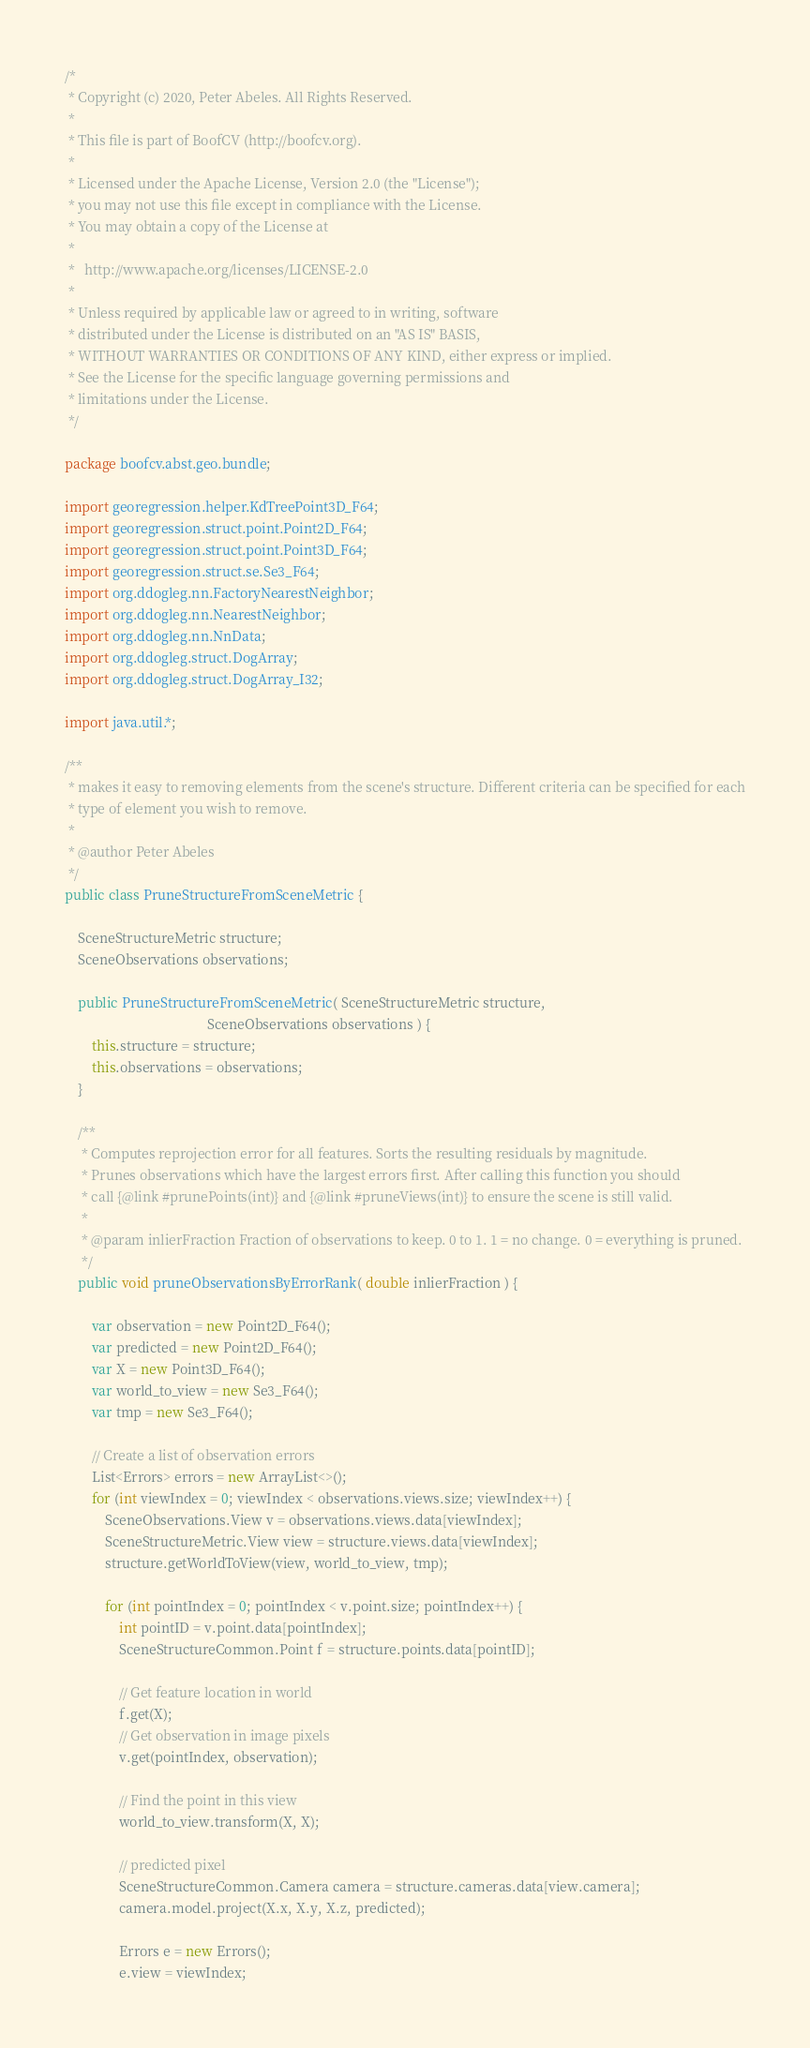Convert code to text. <code><loc_0><loc_0><loc_500><loc_500><_Java_>/*
 * Copyright (c) 2020, Peter Abeles. All Rights Reserved.
 *
 * This file is part of BoofCV (http://boofcv.org).
 *
 * Licensed under the Apache License, Version 2.0 (the "License");
 * you may not use this file except in compliance with the License.
 * You may obtain a copy of the License at
 *
 *   http://www.apache.org/licenses/LICENSE-2.0
 *
 * Unless required by applicable law or agreed to in writing, software
 * distributed under the License is distributed on an "AS IS" BASIS,
 * WITHOUT WARRANTIES OR CONDITIONS OF ANY KIND, either express or implied.
 * See the License for the specific language governing permissions and
 * limitations under the License.
 */

package boofcv.abst.geo.bundle;

import georegression.helper.KdTreePoint3D_F64;
import georegression.struct.point.Point2D_F64;
import georegression.struct.point.Point3D_F64;
import georegression.struct.se.Se3_F64;
import org.ddogleg.nn.FactoryNearestNeighbor;
import org.ddogleg.nn.NearestNeighbor;
import org.ddogleg.nn.NnData;
import org.ddogleg.struct.DogArray;
import org.ddogleg.struct.DogArray_I32;

import java.util.*;

/**
 * makes it easy to removing elements from the scene's structure. Different criteria can be specified for each
 * type of element you wish to remove.
 *
 * @author Peter Abeles
 */
public class PruneStructureFromSceneMetric {

	SceneStructureMetric structure;
	SceneObservations observations;

	public PruneStructureFromSceneMetric( SceneStructureMetric structure,
										  SceneObservations observations ) {
		this.structure = structure;
		this.observations = observations;
	}

	/**
	 * Computes reprojection error for all features. Sorts the resulting residuals by magnitude.
	 * Prunes observations which have the largest errors first. After calling this function you should
	 * call {@link #prunePoints(int)} and {@link #pruneViews(int)} to ensure the scene is still valid.
	 *
	 * @param inlierFraction Fraction of observations to keep. 0 to 1. 1 = no change. 0 = everything is pruned.
	 */
	public void pruneObservationsByErrorRank( double inlierFraction ) {

		var observation = new Point2D_F64();
		var predicted = new Point2D_F64();
		var X = new Point3D_F64();
		var world_to_view = new Se3_F64();
		var tmp = new Se3_F64();

		// Create a list of observation errors
		List<Errors> errors = new ArrayList<>();
		for (int viewIndex = 0; viewIndex < observations.views.size; viewIndex++) {
			SceneObservations.View v = observations.views.data[viewIndex];
			SceneStructureMetric.View view = structure.views.data[viewIndex];
			structure.getWorldToView(view, world_to_view, tmp);

			for (int pointIndex = 0; pointIndex < v.point.size; pointIndex++) {
				int pointID = v.point.data[pointIndex];
				SceneStructureCommon.Point f = structure.points.data[pointID];

				// Get feature location in world
				f.get(X);
				// Get observation in image pixels
				v.get(pointIndex, observation);

				// Find the point in this view
				world_to_view.transform(X, X);

				// predicted pixel
				SceneStructureCommon.Camera camera = structure.cameras.data[view.camera];
				camera.model.project(X.x, X.y, X.z, predicted);

				Errors e = new Errors();
				e.view = viewIndex;</code> 